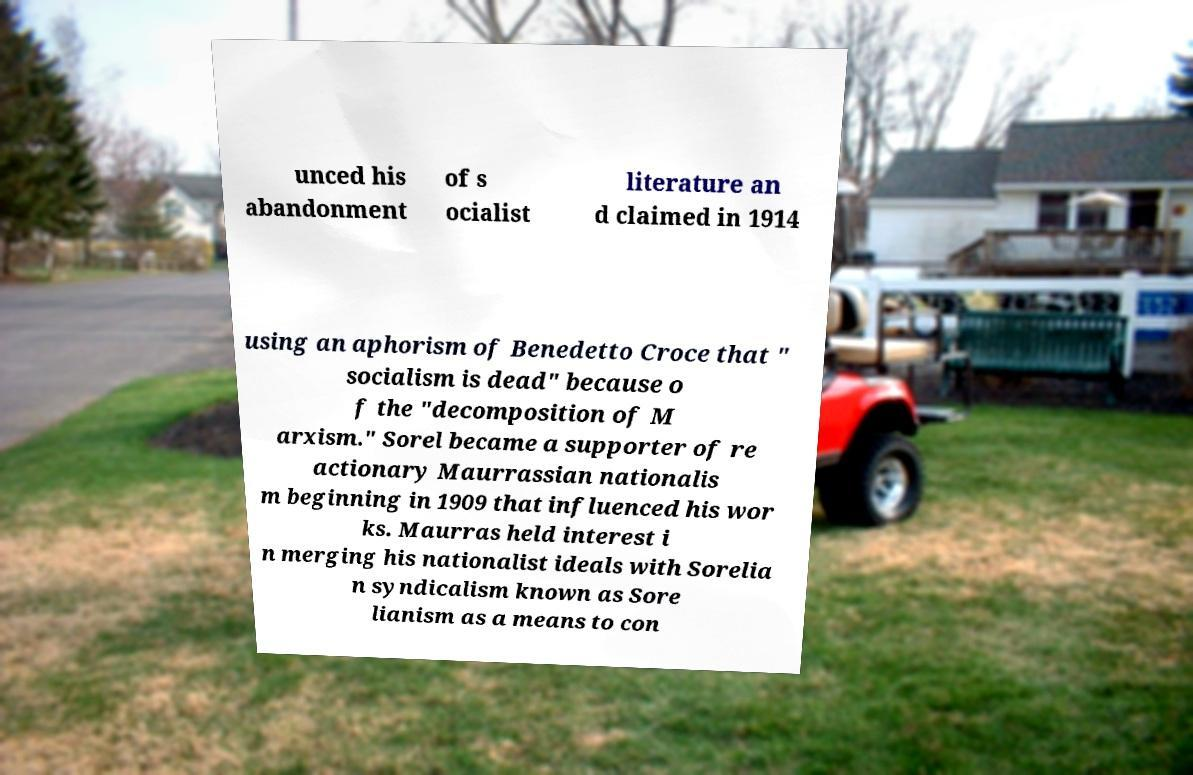Could you assist in decoding the text presented in this image and type it out clearly? unced his abandonment of s ocialist literature an d claimed in 1914 using an aphorism of Benedetto Croce that " socialism is dead" because o f the "decomposition of M arxism." Sorel became a supporter of re actionary Maurrassian nationalis m beginning in 1909 that influenced his wor ks. Maurras held interest i n merging his nationalist ideals with Sorelia n syndicalism known as Sore lianism as a means to con 